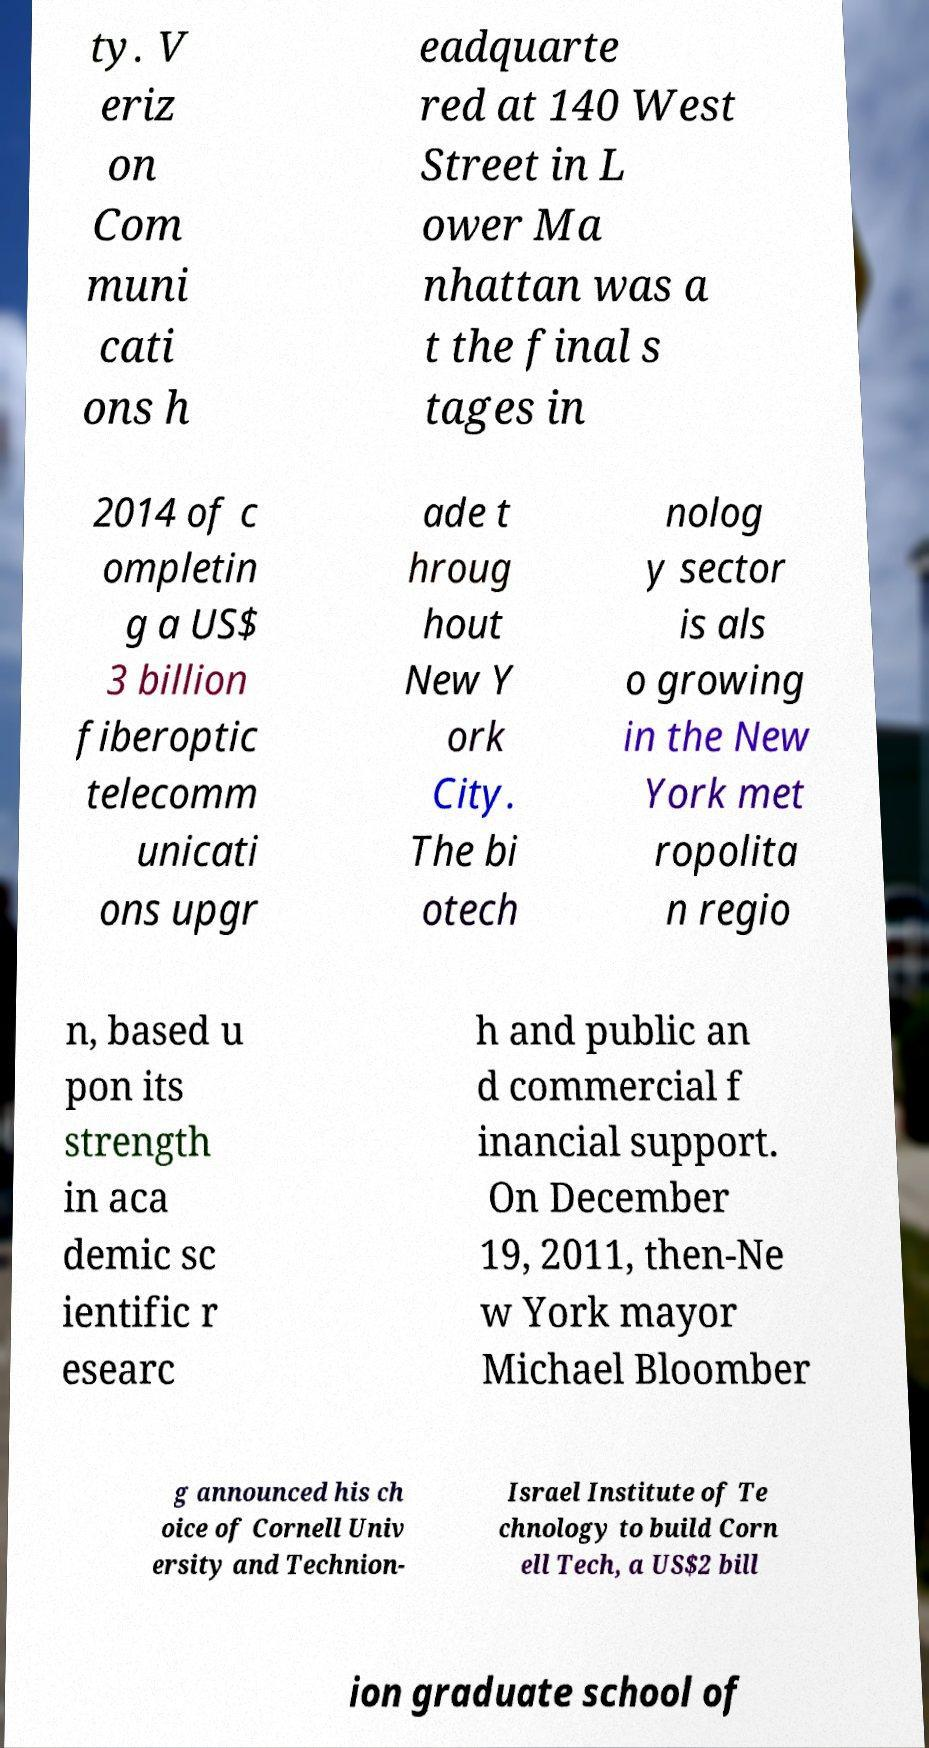Please read and relay the text visible in this image. What does it say? ty. V eriz on Com muni cati ons h eadquarte red at 140 West Street in L ower Ma nhattan was a t the final s tages in 2014 of c ompletin g a US$ 3 billion fiberoptic telecomm unicati ons upgr ade t hroug hout New Y ork City. The bi otech nolog y sector is als o growing in the New York met ropolita n regio n, based u pon its strength in aca demic sc ientific r esearc h and public an d commercial f inancial support. On December 19, 2011, then-Ne w York mayor Michael Bloomber g announced his ch oice of Cornell Univ ersity and Technion- Israel Institute of Te chnology to build Corn ell Tech, a US$2 bill ion graduate school of 